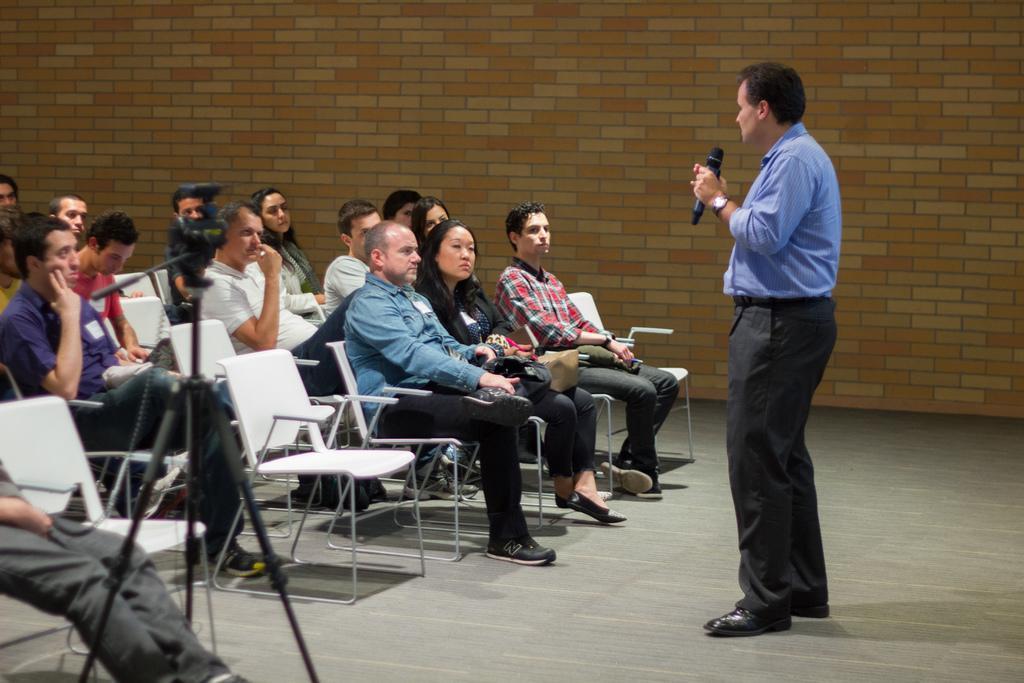Please provide a concise description of this image. In this image there are group of people sitting in a chair , there is a camera fixed to a tripod stand and a man standing and talking in the microphone. 